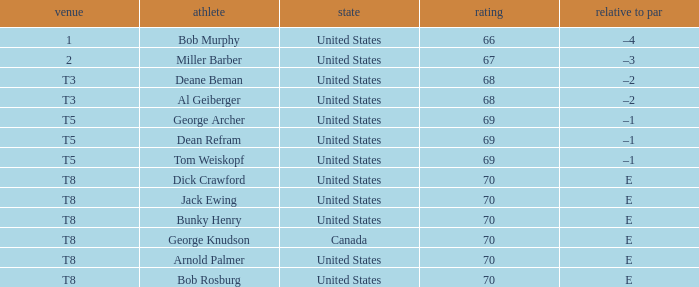Which country is George Archer from? United States. 